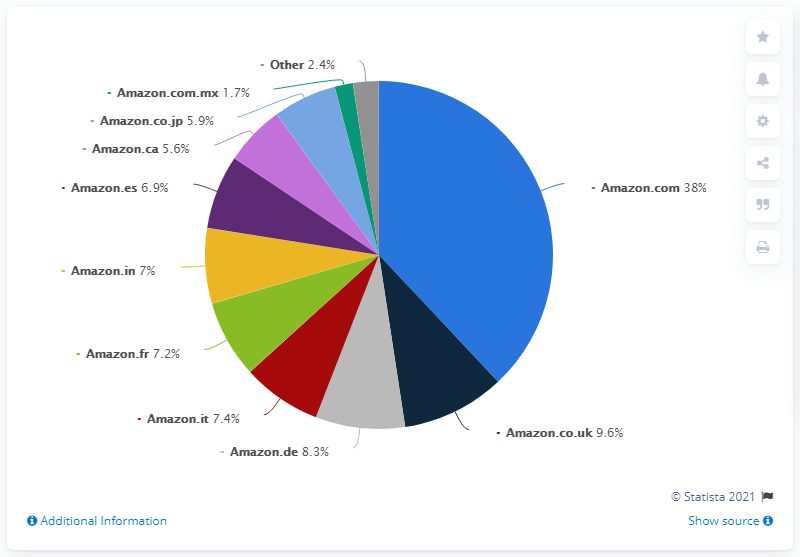Highlight a few significant elements in this photo. Approximately 7% of the world's countries have a population of 3 or fewer. Amazon.com is significantly larger than Amazon.co.uk. 